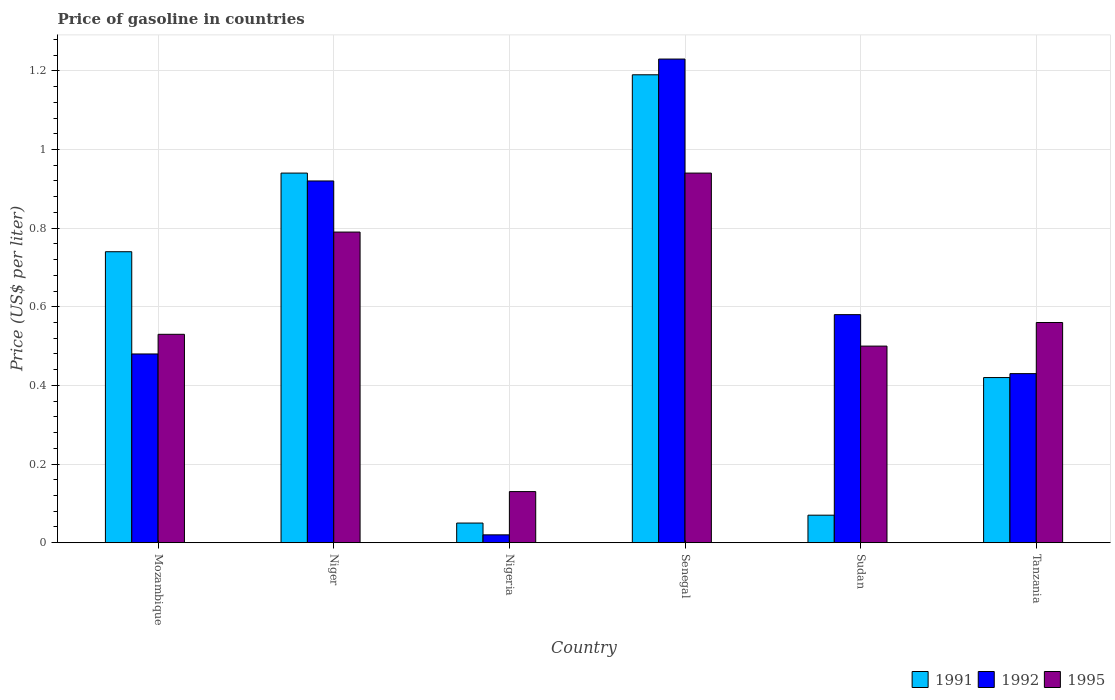How many different coloured bars are there?
Keep it short and to the point. 3. Are the number of bars per tick equal to the number of legend labels?
Make the answer very short. Yes. Are the number of bars on each tick of the X-axis equal?
Your response must be concise. Yes. How many bars are there on the 1st tick from the left?
Offer a terse response. 3. How many bars are there on the 3rd tick from the right?
Give a very brief answer. 3. What is the label of the 2nd group of bars from the left?
Give a very brief answer. Niger. In how many cases, is the number of bars for a given country not equal to the number of legend labels?
Your answer should be compact. 0. What is the price of gasoline in 1992 in Sudan?
Keep it short and to the point. 0.58. Across all countries, what is the maximum price of gasoline in 1995?
Your response must be concise. 0.94. Across all countries, what is the minimum price of gasoline in 1995?
Provide a short and direct response. 0.13. In which country was the price of gasoline in 1992 maximum?
Offer a terse response. Senegal. In which country was the price of gasoline in 1991 minimum?
Your answer should be very brief. Nigeria. What is the total price of gasoline in 1995 in the graph?
Your answer should be compact. 3.45. What is the difference between the price of gasoline in 1995 in Mozambique and that in Senegal?
Give a very brief answer. -0.41. What is the difference between the price of gasoline in 1995 in Tanzania and the price of gasoline in 1992 in Mozambique?
Your answer should be very brief. 0.08. What is the average price of gasoline in 1995 per country?
Your answer should be very brief. 0.58. What is the difference between the price of gasoline of/in 1992 and price of gasoline of/in 1991 in Mozambique?
Ensure brevity in your answer.  -0.26. In how many countries, is the price of gasoline in 1995 greater than 0.2 US$?
Offer a very short reply. 5. What is the ratio of the price of gasoline in 1991 in Nigeria to that in Tanzania?
Ensure brevity in your answer.  0.12. What is the difference between the highest and the second highest price of gasoline in 1991?
Provide a short and direct response. -0.25. What is the difference between the highest and the lowest price of gasoline in 1991?
Provide a short and direct response. 1.14. In how many countries, is the price of gasoline in 1992 greater than the average price of gasoline in 1992 taken over all countries?
Provide a succinct answer. 2. Is the sum of the price of gasoline in 1992 in Niger and Senegal greater than the maximum price of gasoline in 1991 across all countries?
Your answer should be very brief. Yes. What does the 3rd bar from the left in Mozambique represents?
Offer a terse response. 1995. Is it the case that in every country, the sum of the price of gasoline in 1992 and price of gasoline in 1995 is greater than the price of gasoline in 1991?
Offer a terse response. Yes. How many bars are there?
Provide a short and direct response. 18. Are all the bars in the graph horizontal?
Ensure brevity in your answer.  No. What is the difference between two consecutive major ticks on the Y-axis?
Keep it short and to the point. 0.2. Are the values on the major ticks of Y-axis written in scientific E-notation?
Make the answer very short. No. Does the graph contain grids?
Offer a terse response. Yes. How many legend labels are there?
Make the answer very short. 3. What is the title of the graph?
Provide a succinct answer. Price of gasoline in countries. Does "2001" appear as one of the legend labels in the graph?
Provide a succinct answer. No. What is the label or title of the Y-axis?
Offer a very short reply. Price (US$ per liter). What is the Price (US$ per liter) of 1991 in Mozambique?
Your response must be concise. 0.74. What is the Price (US$ per liter) of 1992 in Mozambique?
Offer a terse response. 0.48. What is the Price (US$ per liter) in 1995 in Mozambique?
Offer a very short reply. 0.53. What is the Price (US$ per liter) of 1995 in Niger?
Provide a short and direct response. 0.79. What is the Price (US$ per liter) in 1992 in Nigeria?
Give a very brief answer. 0.02. What is the Price (US$ per liter) of 1995 in Nigeria?
Give a very brief answer. 0.13. What is the Price (US$ per liter) in 1991 in Senegal?
Your answer should be very brief. 1.19. What is the Price (US$ per liter) of 1992 in Senegal?
Your response must be concise. 1.23. What is the Price (US$ per liter) of 1991 in Sudan?
Provide a short and direct response. 0.07. What is the Price (US$ per liter) of 1992 in Sudan?
Your answer should be compact. 0.58. What is the Price (US$ per liter) of 1995 in Sudan?
Provide a short and direct response. 0.5. What is the Price (US$ per liter) in 1991 in Tanzania?
Ensure brevity in your answer.  0.42. What is the Price (US$ per liter) in 1992 in Tanzania?
Ensure brevity in your answer.  0.43. What is the Price (US$ per liter) of 1995 in Tanzania?
Keep it short and to the point. 0.56. Across all countries, what is the maximum Price (US$ per liter) in 1991?
Keep it short and to the point. 1.19. Across all countries, what is the maximum Price (US$ per liter) of 1992?
Your answer should be compact. 1.23. Across all countries, what is the minimum Price (US$ per liter) in 1995?
Provide a short and direct response. 0.13. What is the total Price (US$ per liter) in 1991 in the graph?
Offer a terse response. 3.41. What is the total Price (US$ per liter) in 1992 in the graph?
Keep it short and to the point. 3.66. What is the total Price (US$ per liter) of 1995 in the graph?
Provide a short and direct response. 3.45. What is the difference between the Price (US$ per liter) in 1991 in Mozambique and that in Niger?
Your response must be concise. -0.2. What is the difference between the Price (US$ per liter) in 1992 in Mozambique and that in Niger?
Offer a very short reply. -0.44. What is the difference between the Price (US$ per liter) in 1995 in Mozambique and that in Niger?
Make the answer very short. -0.26. What is the difference between the Price (US$ per liter) of 1991 in Mozambique and that in Nigeria?
Your response must be concise. 0.69. What is the difference between the Price (US$ per liter) in 1992 in Mozambique and that in Nigeria?
Ensure brevity in your answer.  0.46. What is the difference between the Price (US$ per liter) in 1995 in Mozambique and that in Nigeria?
Provide a succinct answer. 0.4. What is the difference between the Price (US$ per liter) of 1991 in Mozambique and that in Senegal?
Provide a short and direct response. -0.45. What is the difference between the Price (US$ per liter) in 1992 in Mozambique and that in Senegal?
Provide a short and direct response. -0.75. What is the difference between the Price (US$ per liter) in 1995 in Mozambique and that in Senegal?
Your answer should be very brief. -0.41. What is the difference between the Price (US$ per liter) in 1991 in Mozambique and that in Sudan?
Offer a very short reply. 0.67. What is the difference between the Price (US$ per liter) of 1992 in Mozambique and that in Sudan?
Your response must be concise. -0.1. What is the difference between the Price (US$ per liter) of 1995 in Mozambique and that in Sudan?
Provide a succinct answer. 0.03. What is the difference between the Price (US$ per liter) of 1991 in Mozambique and that in Tanzania?
Provide a short and direct response. 0.32. What is the difference between the Price (US$ per liter) of 1995 in Mozambique and that in Tanzania?
Offer a terse response. -0.03. What is the difference between the Price (US$ per liter) of 1991 in Niger and that in Nigeria?
Offer a terse response. 0.89. What is the difference between the Price (US$ per liter) of 1995 in Niger and that in Nigeria?
Ensure brevity in your answer.  0.66. What is the difference between the Price (US$ per liter) of 1992 in Niger and that in Senegal?
Provide a short and direct response. -0.31. What is the difference between the Price (US$ per liter) in 1991 in Niger and that in Sudan?
Your answer should be compact. 0.87. What is the difference between the Price (US$ per liter) of 1992 in Niger and that in Sudan?
Provide a short and direct response. 0.34. What is the difference between the Price (US$ per liter) of 1995 in Niger and that in Sudan?
Your response must be concise. 0.29. What is the difference between the Price (US$ per liter) of 1991 in Niger and that in Tanzania?
Offer a terse response. 0.52. What is the difference between the Price (US$ per liter) in 1992 in Niger and that in Tanzania?
Your response must be concise. 0.49. What is the difference between the Price (US$ per liter) of 1995 in Niger and that in Tanzania?
Offer a very short reply. 0.23. What is the difference between the Price (US$ per liter) in 1991 in Nigeria and that in Senegal?
Make the answer very short. -1.14. What is the difference between the Price (US$ per liter) of 1992 in Nigeria and that in Senegal?
Give a very brief answer. -1.21. What is the difference between the Price (US$ per liter) in 1995 in Nigeria and that in Senegal?
Make the answer very short. -0.81. What is the difference between the Price (US$ per liter) of 1991 in Nigeria and that in Sudan?
Your response must be concise. -0.02. What is the difference between the Price (US$ per liter) of 1992 in Nigeria and that in Sudan?
Offer a terse response. -0.56. What is the difference between the Price (US$ per liter) in 1995 in Nigeria and that in Sudan?
Provide a short and direct response. -0.37. What is the difference between the Price (US$ per liter) of 1991 in Nigeria and that in Tanzania?
Your answer should be very brief. -0.37. What is the difference between the Price (US$ per liter) in 1992 in Nigeria and that in Tanzania?
Your response must be concise. -0.41. What is the difference between the Price (US$ per liter) of 1995 in Nigeria and that in Tanzania?
Your answer should be compact. -0.43. What is the difference between the Price (US$ per liter) in 1991 in Senegal and that in Sudan?
Keep it short and to the point. 1.12. What is the difference between the Price (US$ per liter) of 1992 in Senegal and that in Sudan?
Your response must be concise. 0.65. What is the difference between the Price (US$ per liter) of 1995 in Senegal and that in Sudan?
Ensure brevity in your answer.  0.44. What is the difference between the Price (US$ per liter) in 1991 in Senegal and that in Tanzania?
Give a very brief answer. 0.77. What is the difference between the Price (US$ per liter) of 1992 in Senegal and that in Tanzania?
Offer a very short reply. 0.8. What is the difference between the Price (US$ per liter) of 1995 in Senegal and that in Tanzania?
Give a very brief answer. 0.38. What is the difference between the Price (US$ per liter) of 1991 in Sudan and that in Tanzania?
Offer a terse response. -0.35. What is the difference between the Price (US$ per liter) in 1992 in Sudan and that in Tanzania?
Your response must be concise. 0.15. What is the difference between the Price (US$ per liter) of 1995 in Sudan and that in Tanzania?
Make the answer very short. -0.06. What is the difference between the Price (US$ per liter) in 1991 in Mozambique and the Price (US$ per liter) in 1992 in Niger?
Your response must be concise. -0.18. What is the difference between the Price (US$ per liter) of 1991 in Mozambique and the Price (US$ per liter) of 1995 in Niger?
Provide a succinct answer. -0.05. What is the difference between the Price (US$ per liter) in 1992 in Mozambique and the Price (US$ per liter) in 1995 in Niger?
Offer a terse response. -0.31. What is the difference between the Price (US$ per liter) in 1991 in Mozambique and the Price (US$ per liter) in 1992 in Nigeria?
Your answer should be compact. 0.72. What is the difference between the Price (US$ per liter) in 1991 in Mozambique and the Price (US$ per liter) in 1995 in Nigeria?
Give a very brief answer. 0.61. What is the difference between the Price (US$ per liter) in 1992 in Mozambique and the Price (US$ per liter) in 1995 in Nigeria?
Offer a very short reply. 0.35. What is the difference between the Price (US$ per liter) of 1991 in Mozambique and the Price (US$ per liter) of 1992 in Senegal?
Your response must be concise. -0.49. What is the difference between the Price (US$ per liter) of 1991 in Mozambique and the Price (US$ per liter) of 1995 in Senegal?
Provide a short and direct response. -0.2. What is the difference between the Price (US$ per liter) of 1992 in Mozambique and the Price (US$ per liter) of 1995 in Senegal?
Offer a very short reply. -0.46. What is the difference between the Price (US$ per liter) of 1991 in Mozambique and the Price (US$ per liter) of 1992 in Sudan?
Provide a succinct answer. 0.16. What is the difference between the Price (US$ per liter) of 1991 in Mozambique and the Price (US$ per liter) of 1995 in Sudan?
Make the answer very short. 0.24. What is the difference between the Price (US$ per liter) of 1992 in Mozambique and the Price (US$ per liter) of 1995 in Sudan?
Offer a very short reply. -0.02. What is the difference between the Price (US$ per liter) of 1991 in Mozambique and the Price (US$ per liter) of 1992 in Tanzania?
Provide a succinct answer. 0.31. What is the difference between the Price (US$ per liter) of 1991 in Mozambique and the Price (US$ per liter) of 1995 in Tanzania?
Make the answer very short. 0.18. What is the difference between the Price (US$ per liter) in 1992 in Mozambique and the Price (US$ per liter) in 1995 in Tanzania?
Offer a very short reply. -0.08. What is the difference between the Price (US$ per liter) of 1991 in Niger and the Price (US$ per liter) of 1995 in Nigeria?
Provide a short and direct response. 0.81. What is the difference between the Price (US$ per liter) of 1992 in Niger and the Price (US$ per liter) of 1995 in Nigeria?
Keep it short and to the point. 0.79. What is the difference between the Price (US$ per liter) of 1991 in Niger and the Price (US$ per liter) of 1992 in Senegal?
Provide a short and direct response. -0.29. What is the difference between the Price (US$ per liter) in 1992 in Niger and the Price (US$ per liter) in 1995 in Senegal?
Your answer should be very brief. -0.02. What is the difference between the Price (US$ per liter) of 1991 in Niger and the Price (US$ per liter) of 1992 in Sudan?
Make the answer very short. 0.36. What is the difference between the Price (US$ per liter) of 1991 in Niger and the Price (US$ per liter) of 1995 in Sudan?
Offer a very short reply. 0.44. What is the difference between the Price (US$ per liter) of 1992 in Niger and the Price (US$ per liter) of 1995 in Sudan?
Make the answer very short. 0.42. What is the difference between the Price (US$ per liter) in 1991 in Niger and the Price (US$ per liter) in 1992 in Tanzania?
Your answer should be very brief. 0.51. What is the difference between the Price (US$ per liter) in 1991 in Niger and the Price (US$ per liter) in 1995 in Tanzania?
Make the answer very short. 0.38. What is the difference between the Price (US$ per liter) of 1992 in Niger and the Price (US$ per liter) of 1995 in Tanzania?
Offer a very short reply. 0.36. What is the difference between the Price (US$ per liter) of 1991 in Nigeria and the Price (US$ per liter) of 1992 in Senegal?
Your answer should be compact. -1.18. What is the difference between the Price (US$ per liter) of 1991 in Nigeria and the Price (US$ per liter) of 1995 in Senegal?
Your answer should be compact. -0.89. What is the difference between the Price (US$ per liter) in 1992 in Nigeria and the Price (US$ per liter) in 1995 in Senegal?
Make the answer very short. -0.92. What is the difference between the Price (US$ per liter) of 1991 in Nigeria and the Price (US$ per liter) of 1992 in Sudan?
Ensure brevity in your answer.  -0.53. What is the difference between the Price (US$ per liter) of 1991 in Nigeria and the Price (US$ per liter) of 1995 in Sudan?
Make the answer very short. -0.45. What is the difference between the Price (US$ per liter) of 1992 in Nigeria and the Price (US$ per liter) of 1995 in Sudan?
Offer a terse response. -0.48. What is the difference between the Price (US$ per liter) of 1991 in Nigeria and the Price (US$ per liter) of 1992 in Tanzania?
Offer a very short reply. -0.38. What is the difference between the Price (US$ per liter) of 1991 in Nigeria and the Price (US$ per liter) of 1995 in Tanzania?
Give a very brief answer. -0.51. What is the difference between the Price (US$ per liter) of 1992 in Nigeria and the Price (US$ per liter) of 1995 in Tanzania?
Make the answer very short. -0.54. What is the difference between the Price (US$ per liter) of 1991 in Senegal and the Price (US$ per liter) of 1992 in Sudan?
Make the answer very short. 0.61. What is the difference between the Price (US$ per liter) of 1991 in Senegal and the Price (US$ per liter) of 1995 in Sudan?
Your answer should be very brief. 0.69. What is the difference between the Price (US$ per liter) in 1992 in Senegal and the Price (US$ per liter) in 1995 in Sudan?
Make the answer very short. 0.73. What is the difference between the Price (US$ per liter) of 1991 in Senegal and the Price (US$ per liter) of 1992 in Tanzania?
Ensure brevity in your answer.  0.76. What is the difference between the Price (US$ per liter) of 1991 in Senegal and the Price (US$ per liter) of 1995 in Tanzania?
Offer a very short reply. 0.63. What is the difference between the Price (US$ per liter) of 1992 in Senegal and the Price (US$ per liter) of 1995 in Tanzania?
Offer a very short reply. 0.67. What is the difference between the Price (US$ per liter) of 1991 in Sudan and the Price (US$ per liter) of 1992 in Tanzania?
Offer a very short reply. -0.36. What is the difference between the Price (US$ per liter) in 1991 in Sudan and the Price (US$ per liter) in 1995 in Tanzania?
Give a very brief answer. -0.49. What is the difference between the Price (US$ per liter) in 1992 in Sudan and the Price (US$ per liter) in 1995 in Tanzania?
Ensure brevity in your answer.  0.02. What is the average Price (US$ per liter) of 1991 per country?
Provide a succinct answer. 0.57. What is the average Price (US$ per liter) in 1992 per country?
Offer a terse response. 0.61. What is the average Price (US$ per liter) in 1995 per country?
Keep it short and to the point. 0.57. What is the difference between the Price (US$ per liter) in 1991 and Price (US$ per liter) in 1992 in Mozambique?
Make the answer very short. 0.26. What is the difference between the Price (US$ per liter) in 1991 and Price (US$ per liter) in 1995 in Mozambique?
Make the answer very short. 0.21. What is the difference between the Price (US$ per liter) in 1992 and Price (US$ per liter) in 1995 in Mozambique?
Offer a very short reply. -0.05. What is the difference between the Price (US$ per liter) in 1992 and Price (US$ per liter) in 1995 in Niger?
Ensure brevity in your answer.  0.13. What is the difference between the Price (US$ per liter) in 1991 and Price (US$ per liter) in 1995 in Nigeria?
Offer a very short reply. -0.08. What is the difference between the Price (US$ per liter) in 1992 and Price (US$ per liter) in 1995 in Nigeria?
Your response must be concise. -0.11. What is the difference between the Price (US$ per liter) of 1991 and Price (US$ per liter) of 1992 in Senegal?
Your response must be concise. -0.04. What is the difference between the Price (US$ per liter) of 1992 and Price (US$ per liter) of 1995 in Senegal?
Provide a short and direct response. 0.29. What is the difference between the Price (US$ per liter) of 1991 and Price (US$ per liter) of 1992 in Sudan?
Your response must be concise. -0.51. What is the difference between the Price (US$ per liter) of 1991 and Price (US$ per liter) of 1995 in Sudan?
Provide a short and direct response. -0.43. What is the difference between the Price (US$ per liter) in 1991 and Price (US$ per liter) in 1992 in Tanzania?
Your answer should be compact. -0.01. What is the difference between the Price (US$ per liter) of 1991 and Price (US$ per liter) of 1995 in Tanzania?
Offer a terse response. -0.14. What is the difference between the Price (US$ per liter) in 1992 and Price (US$ per liter) in 1995 in Tanzania?
Provide a succinct answer. -0.13. What is the ratio of the Price (US$ per liter) in 1991 in Mozambique to that in Niger?
Offer a terse response. 0.79. What is the ratio of the Price (US$ per liter) of 1992 in Mozambique to that in Niger?
Make the answer very short. 0.52. What is the ratio of the Price (US$ per liter) of 1995 in Mozambique to that in Niger?
Give a very brief answer. 0.67. What is the ratio of the Price (US$ per liter) of 1991 in Mozambique to that in Nigeria?
Give a very brief answer. 14.8. What is the ratio of the Price (US$ per liter) in 1992 in Mozambique to that in Nigeria?
Provide a short and direct response. 24. What is the ratio of the Price (US$ per liter) in 1995 in Mozambique to that in Nigeria?
Your response must be concise. 4.08. What is the ratio of the Price (US$ per liter) of 1991 in Mozambique to that in Senegal?
Ensure brevity in your answer.  0.62. What is the ratio of the Price (US$ per liter) of 1992 in Mozambique to that in Senegal?
Ensure brevity in your answer.  0.39. What is the ratio of the Price (US$ per liter) of 1995 in Mozambique to that in Senegal?
Your answer should be compact. 0.56. What is the ratio of the Price (US$ per liter) of 1991 in Mozambique to that in Sudan?
Offer a terse response. 10.57. What is the ratio of the Price (US$ per liter) of 1992 in Mozambique to that in Sudan?
Your answer should be very brief. 0.83. What is the ratio of the Price (US$ per liter) in 1995 in Mozambique to that in Sudan?
Provide a succinct answer. 1.06. What is the ratio of the Price (US$ per liter) in 1991 in Mozambique to that in Tanzania?
Your answer should be compact. 1.76. What is the ratio of the Price (US$ per liter) of 1992 in Mozambique to that in Tanzania?
Your answer should be compact. 1.12. What is the ratio of the Price (US$ per liter) of 1995 in Mozambique to that in Tanzania?
Provide a succinct answer. 0.95. What is the ratio of the Price (US$ per liter) in 1995 in Niger to that in Nigeria?
Keep it short and to the point. 6.08. What is the ratio of the Price (US$ per liter) in 1991 in Niger to that in Senegal?
Your answer should be very brief. 0.79. What is the ratio of the Price (US$ per liter) of 1992 in Niger to that in Senegal?
Ensure brevity in your answer.  0.75. What is the ratio of the Price (US$ per liter) of 1995 in Niger to that in Senegal?
Give a very brief answer. 0.84. What is the ratio of the Price (US$ per liter) of 1991 in Niger to that in Sudan?
Keep it short and to the point. 13.43. What is the ratio of the Price (US$ per liter) in 1992 in Niger to that in Sudan?
Ensure brevity in your answer.  1.59. What is the ratio of the Price (US$ per liter) of 1995 in Niger to that in Sudan?
Keep it short and to the point. 1.58. What is the ratio of the Price (US$ per liter) of 1991 in Niger to that in Tanzania?
Keep it short and to the point. 2.24. What is the ratio of the Price (US$ per liter) of 1992 in Niger to that in Tanzania?
Offer a very short reply. 2.14. What is the ratio of the Price (US$ per liter) in 1995 in Niger to that in Tanzania?
Ensure brevity in your answer.  1.41. What is the ratio of the Price (US$ per liter) of 1991 in Nigeria to that in Senegal?
Make the answer very short. 0.04. What is the ratio of the Price (US$ per liter) in 1992 in Nigeria to that in Senegal?
Your answer should be compact. 0.02. What is the ratio of the Price (US$ per liter) in 1995 in Nigeria to that in Senegal?
Provide a short and direct response. 0.14. What is the ratio of the Price (US$ per liter) of 1991 in Nigeria to that in Sudan?
Offer a terse response. 0.71. What is the ratio of the Price (US$ per liter) of 1992 in Nigeria to that in Sudan?
Give a very brief answer. 0.03. What is the ratio of the Price (US$ per liter) of 1995 in Nigeria to that in Sudan?
Provide a short and direct response. 0.26. What is the ratio of the Price (US$ per liter) of 1991 in Nigeria to that in Tanzania?
Ensure brevity in your answer.  0.12. What is the ratio of the Price (US$ per liter) in 1992 in Nigeria to that in Tanzania?
Your answer should be compact. 0.05. What is the ratio of the Price (US$ per liter) in 1995 in Nigeria to that in Tanzania?
Offer a very short reply. 0.23. What is the ratio of the Price (US$ per liter) of 1992 in Senegal to that in Sudan?
Your response must be concise. 2.12. What is the ratio of the Price (US$ per liter) of 1995 in Senegal to that in Sudan?
Give a very brief answer. 1.88. What is the ratio of the Price (US$ per liter) in 1991 in Senegal to that in Tanzania?
Your response must be concise. 2.83. What is the ratio of the Price (US$ per liter) in 1992 in Senegal to that in Tanzania?
Your answer should be very brief. 2.86. What is the ratio of the Price (US$ per liter) in 1995 in Senegal to that in Tanzania?
Ensure brevity in your answer.  1.68. What is the ratio of the Price (US$ per liter) in 1992 in Sudan to that in Tanzania?
Provide a succinct answer. 1.35. What is the ratio of the Price (US$ per liter) of 1995 in Sudan to that in Tanzania?
Keep it short and to the point. 0.89. What is the difference between the highest and the second highest Price (US$ per liter) of 1991?
Offer a terse response. 0.25. What is the difference between the highest and the second highest Price (US$ per liter) of 1992?
Provide a succinct answer. 0.31. What is the difference between the highest and the second highest Price (US$ per liter) of 1995?
Make the answer very short. 0.15. What is the difference between the highest and the lowest Price (US$ per liter) of 1991?
Give a very brief answer. 1.14. What is the difference between the highest and the lowest Price (US$ per liter) of 1992?
Your answer should be very brief. 1.21. What is the difference between the highest and the lowest Price (US$ per liter) in 1995?
Your answer should be compact. 0.81. 